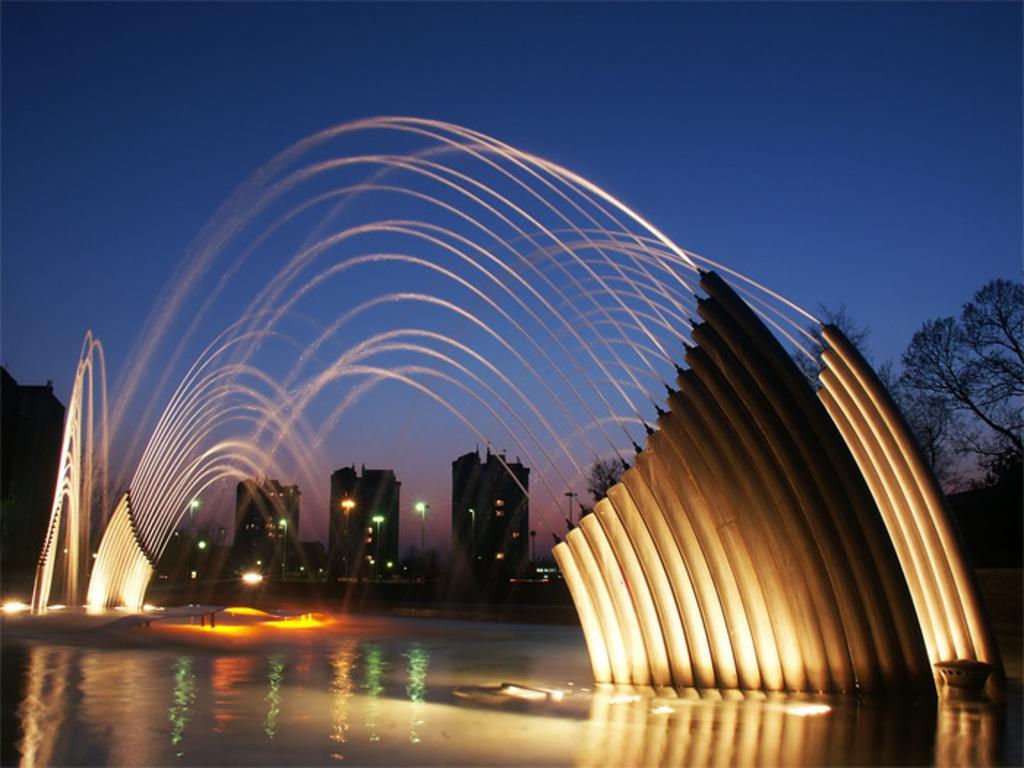Can you describe this image briefly? It's a beautiful waterfall, these are the lights. In the middle there are buildings at the top it's a sky. 